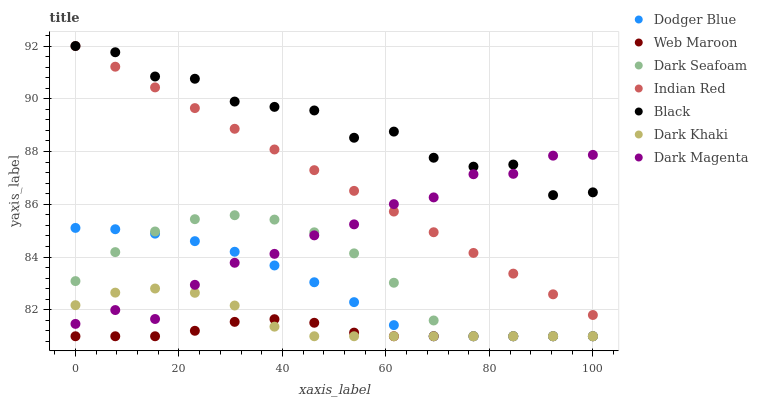Does Web Maroon have the minimum area under the curve?
Answer yes or no. Yes. Does Black have the maximum area under the curve?
Answer yes or no. Yes. Does Dark Khaki have the minimum area under the curve?
Answer yes or no. No. Does Dark Khaki have the maximum area under the curve?
Answer yes or no. No. Is Indian Red the smoothest?
Answer yes or no. Yes. Is Black the roughest?
Answer yes or no. Yes. Is Web Maroon the smoothest?
Answer yes or no. No. Is Web Maroon the roughest?
Answer yes or no. No. Does Web Maroon have the lowest value?
Answer yes or no. Yes. Does Indian Red have the lowest value?
Answer yes or no. No. Does Black have the highest value?
Answer yes or no. Yes. Does Dark Khaki have the highest value?
Answer yes or no. No. Is Web Maroon less than Indian Red?
Answer yes or no. Yes. Is Black greater than Dark Seafoam?
Answer yes or no. Yes. Does Web Maroon intersect Dark Seafoam?
Answer yes or no. Yes. Is Web Maroon less than Dark Seafoam?
Answer yes or no. No. Is Web Maroon greater than Dark Seafoam?
Answer yes or no. No. Does Web Maroon intersect Indian Red?
Answer yes or no. No. 